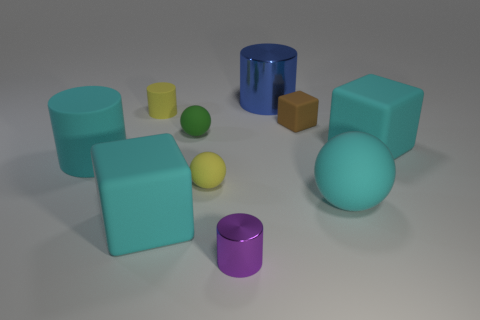How many objects in the image are taller than they are wide? Only one object fulfills that characteristic: the yellow cylinder in the center appears taller than its diameter.  In terms of texture, how would you describe the objects? The objects present a matte texture, with soft lighting revealing a slightly rough surface finish, apart from the blue cylindrical object, which has a smooth and reflective surface. 